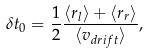<formula> <loc_0><loc_0><loc_500><loc_500>\delta t _ { 0 } = \frac { 1 } { 2 } \frac { \langle r _ { l } \rangle + \langle r _ { r } \rangle } { \langle v _ { d r i f t } \rangle } ,</formula> 